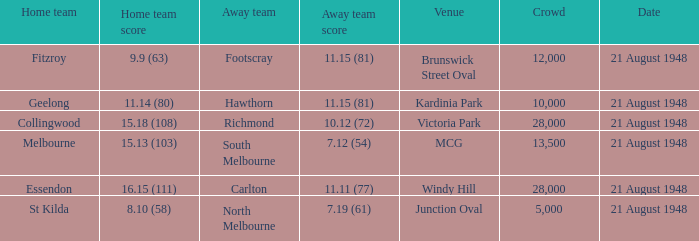If the Away team is north melbourne, what's the Home team score? 8.10 (58). 